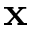Convert formula to latex. <formula><loc_0><loc_0><loc_500><loc_500>x</formula> 